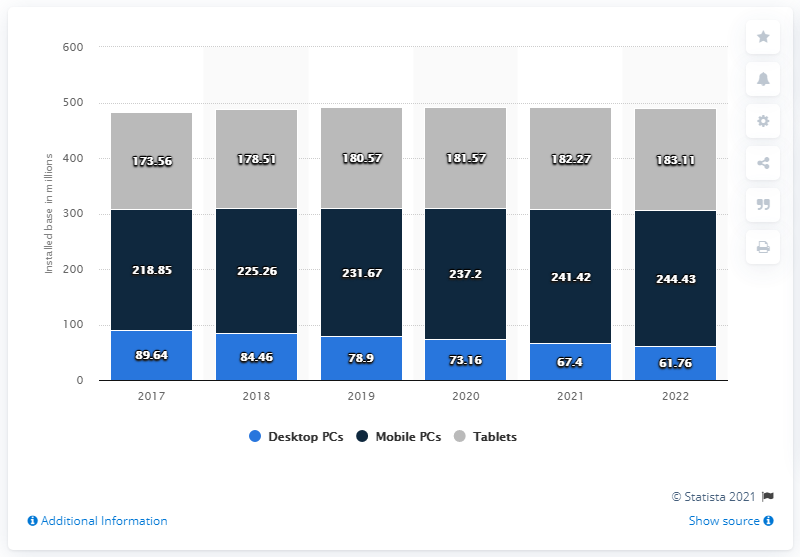Point out several critical features in this image. The estimated installed base of mobile PCs in the U.S. in 2018 was approximately 225.26 million. 